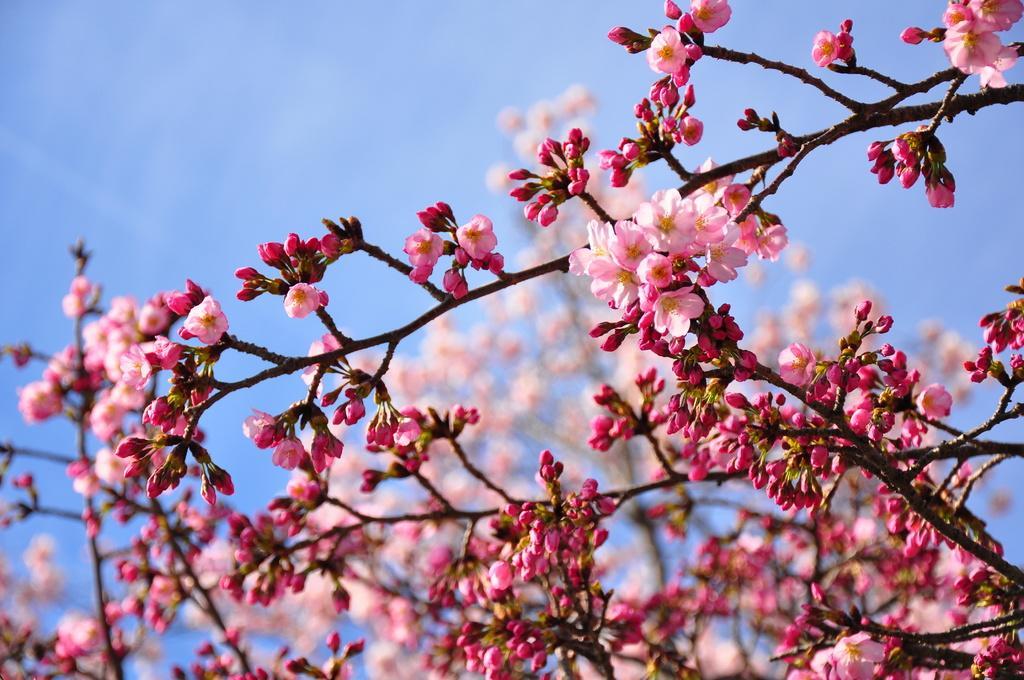Please provide a concise description of this image. In this image there is a tree, there are flowers, the background of the image is blurred, at the background of the image there is the sky. 